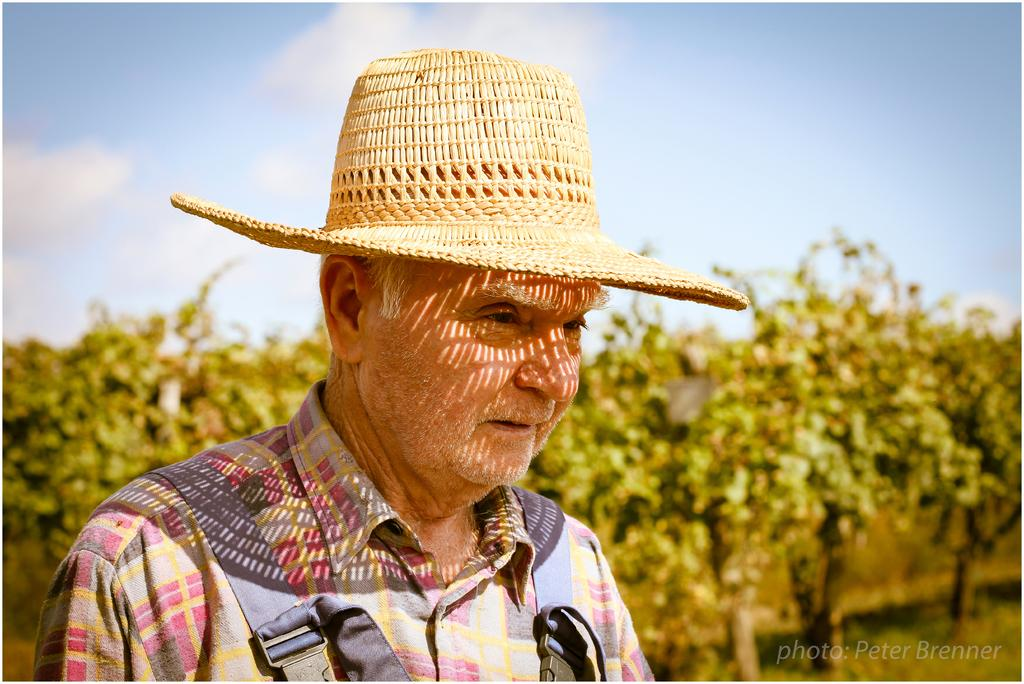Who is present in the image? There is a man in the image. What is the man wearing on his head? The man is wearing a hat. What can be seen in the background of the image? There are trees in the background of the image. What type of test is the man conducting in the image? There is no indication in the image that the man is conducting a test, as he is simply wearing a hat and standing in front of trees. 